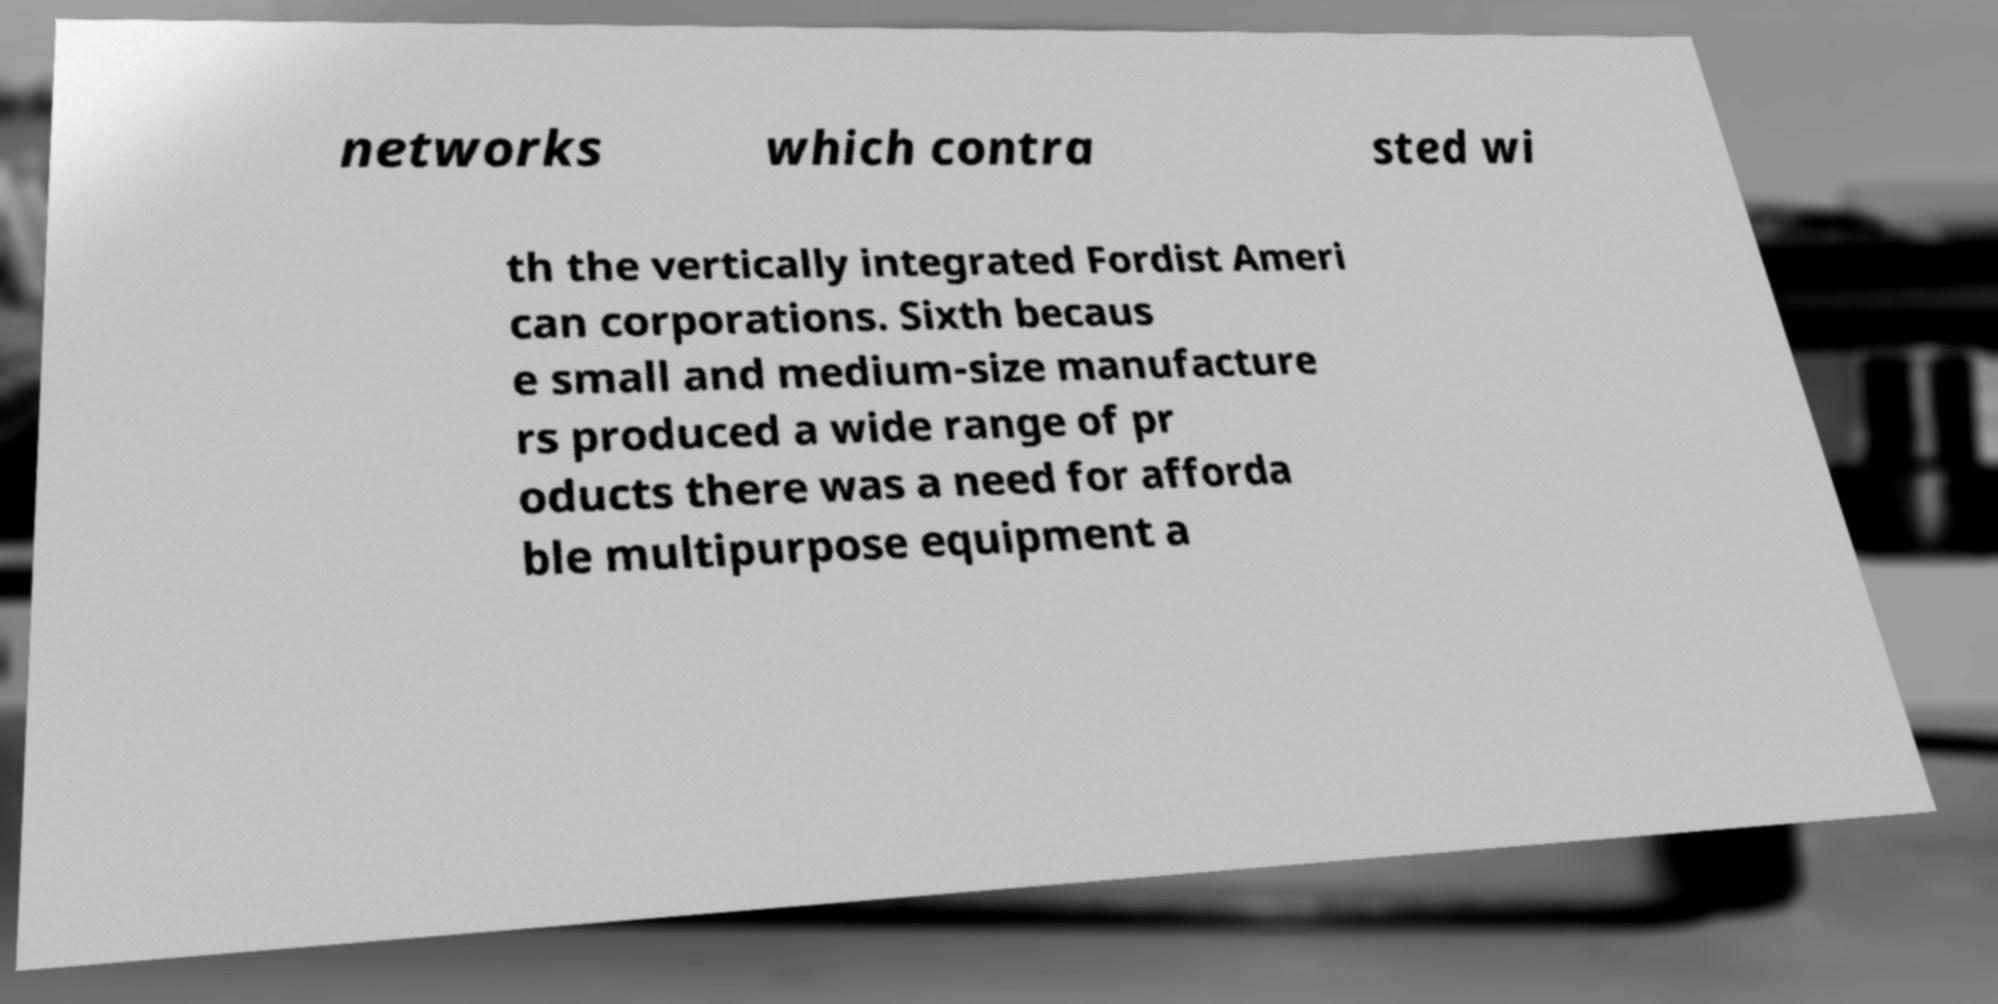Can you read and provide the text displayed in the image?This photo seems to have some interesting text. Can you extract and type it out for me? networks which contra sted wi th the vertically integrated Fordist Ameri can corporations. Sixth becaus e small and medium-size manufacture rs produced a wide range of pr oducts there was a need for afforda ble multipurpose equipment a 